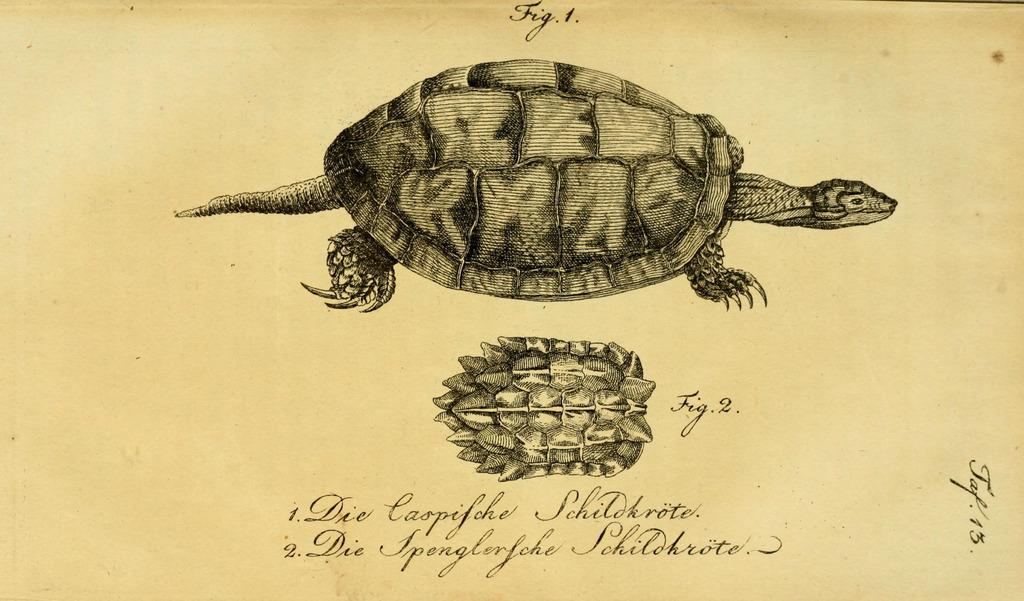What is present on the paper in the image? The paper contains a tortoise diagram and text. Can you describe the tortoise diagram on the paper? Unfortunately, the details of the tortoise diagram cannot be determined from the image alone. What type of information might be conveyed by the text on the paper? The text on the paper could contain information related to the tortoise diagram or another topic entirely. Where is the throne located in the image? There is no throne present in the image. What type of stew is being prepared in the image? There is no stew or cooking activity present in the image. 